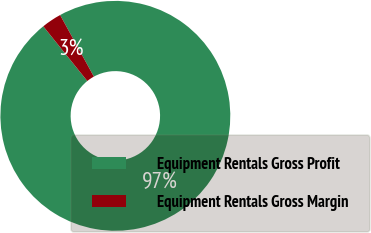Convert chart. <chart><loc_0><loc_0><loc_500><loc_500><pie_chart><fcel>Equipment Rentals Gross Profit<fcel>Equipment Rentals Gross Margin<nl><fcel>97.19%<fcel>2.81%<nl></chart> 